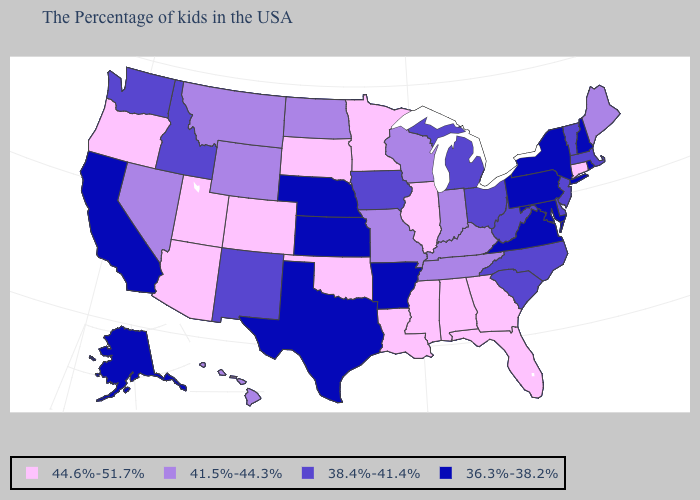Among the states that border Maryland , which have the highest value?
Give a very brief answer. Delaware, West Virginia. Name the states that have a value in the range 44.6%-51.7%?
Quick response, please. Connecticut, Florida, Georgia, Alabama, Illinois, Mississippi, Louisiana, Minnesota, Oklahoma, South Dakota, Colorado, Utah, Arizona, Oregon. Does the map have missing data?
Answer briefly. No. What is the value of Delaware?
Short answer required. 38.4%-41.4%. Name the states that have a value in the range 38.4%-41.4%?
Answer briefly. Massachusetts, Vermont, New Jersey, Delaware, North Carolina, South Carolina, West Virginia, Ohio, Michigan, Iowa, New Mexico, Idaho, Washington. Name the states that have a value in the range 44.6%-51.7%?
Answer briefly. Connecticut, Florida, Georgia, Alabama, Illinois, Mississippi, Louisiana, Minnesota, Oklahoma, South Dakota, Colorado, Utah, Arizona, Oregon. What is the value of Hawaii?
Answer briefly. 41.5%-44.3%. Which states have the lowest value in the USA?
Short answer required. Rhode Island, New Hampshire, New York, Maryland, Pennsylvania, Virginia, Arkansas, Kansas, Nebraska, Texas, California, Alaska. What is the lowest value in the USA?
Give a very brief answer. 36.3%-38.2%. Name the states that have a value in the range 41.5%-44.3%?
Keep it brief. Maine, Kentucky, Indiana, Tennessee, Wisconsin, Missouri, North Dakota, Wyoming, Montana, Nevada, Hawaii. What is the value of Nevada?
Be succinct. 41.5%-44.3%. Among the states that border Ohio , does Indiana have the lowest value?
Be succinct. No. Does New Jersey have the highest value in the Northeast?
Give a very brief answer. No. How many symbols are there in the legend?
Be succinct. 4. What is the value of Wisconsin?
Short answer required. 41.5%-44.3%. 